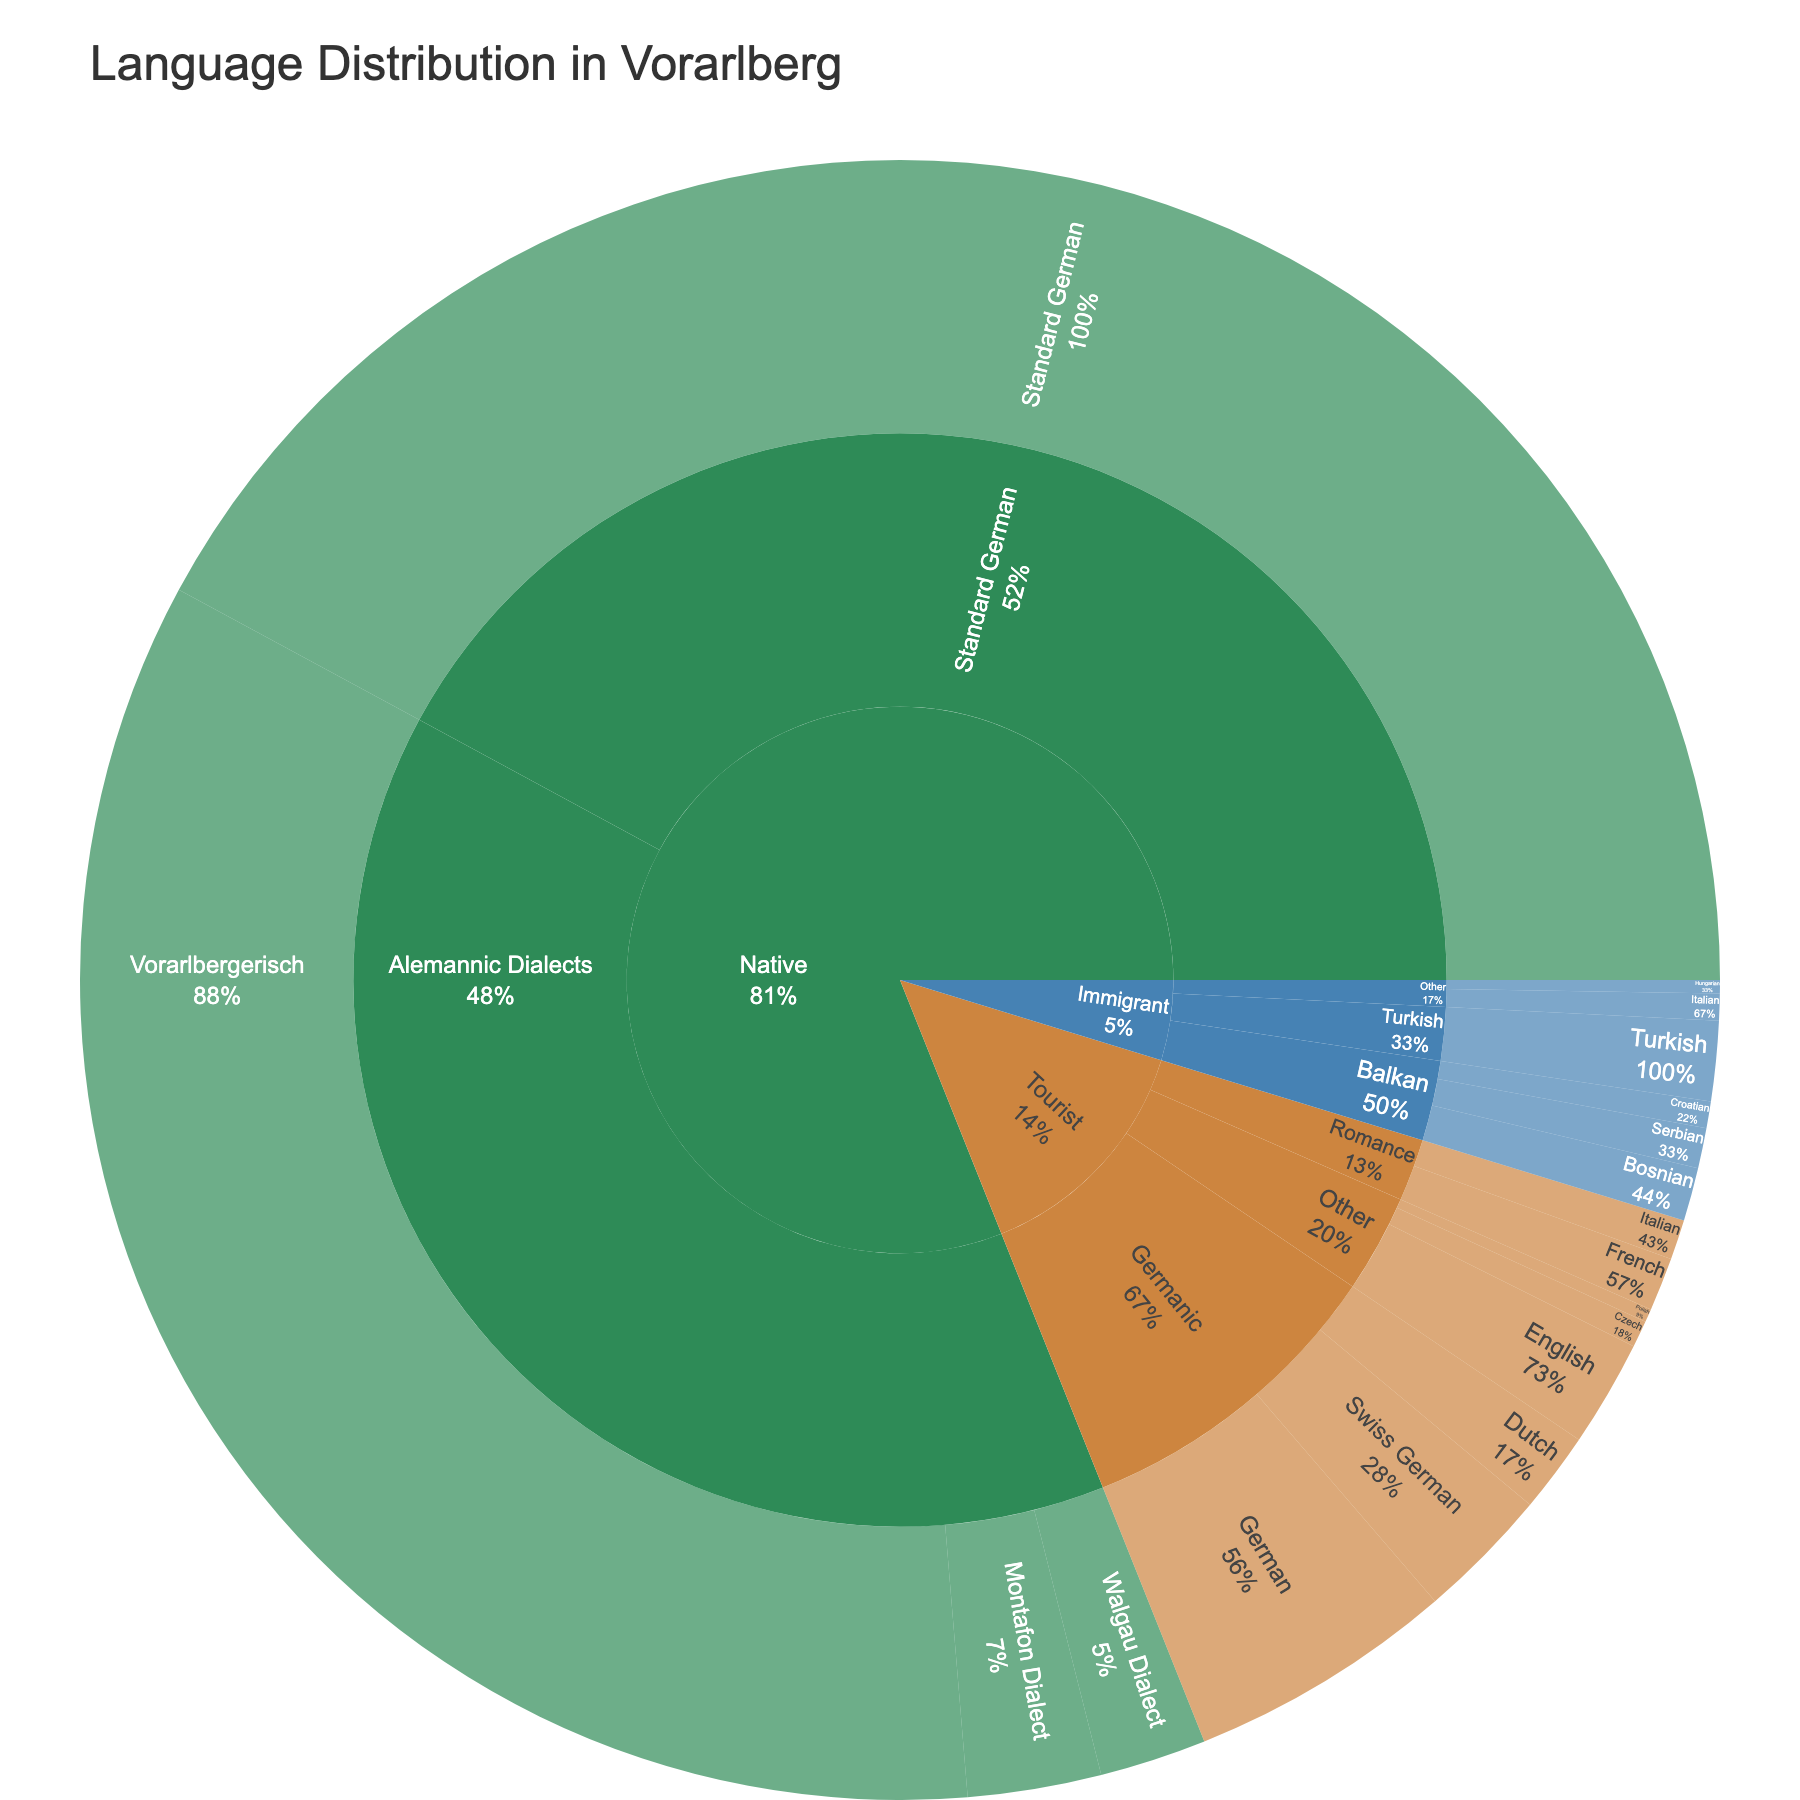What's the title of the figure? The title appears at the top of the figure. It provides a general overview of what the visual information is about.
Answer: Language Distribution in Vorarlberg What color represents the 'Native' category in the sunburst plot? Look for the color associated with the 'Native' category in the legend or the corresponding sections.
Answer: Green What is the percentage of tourists who speak German? Find the 'Tourist' category and then look for 'German' under the 'Germanic' subcategory to read the percentage.
Answer: 10% Can you list all dialects spoken as native languages and their percentages? Locate the 'Native' category and then look for the 'Alemannic Dialects' subcategory to identify and list all dialects and their corresponding percentages given.
Answer: Vorarlbergerisch: 65%, Montafon Dialect: 5%, Walgau Dialect: 4% Which immigrant language has the highest percentage, and what is it? Look under the 'Immigrant' category and compare the percentages of the languages listed to find the highest one.
Answer: Turkish: 3% How many different subcategories exist under the 'Tourist' category? Count the number of subcategories under the 'Tourist' category in the plot.
Answer: 3 (Germanic, Romance, Other) What's the combined percentage of Balkan languages spoken by immigrants? Sum the percentages of Bosnian, Serbian, and Croatian under the 'Balkan' subcategory of 'Immigrant'.
Answer: 2% + 1.5% + 1% = 4.5% Which category has the color brown in the sunburst plot? Identify the category with the brown color by referring to the legend.
Answer: Tourist Is Vorarlbergerisch spoken more frequently as a native language than Standard German? Compare the percentage of Vorarlbergerisch (under Alemannic Dialects) with Standard German in the Native category.
Answer: No What's the total percentage of all foreign languages spoken by tourists? Add the percentages of all languages under the 'Tourist' category across its subcategories.
Answer: 10% + 5% + 3% + 2% + 1.5% + 4% + 1% + 0.5% = 27% 